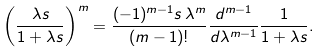Convert formula to latex. <formula><loc_0><loc_0><loc_500><loc_500>\left ( \frac { \lambda s } { 1 + \lambda s } \right ) ^ { m } = \frac { ( - 1 ) ^ { m - 1 } s \, \lambda ^ { m } } { ( m - 1 ) ! } \frac { d ^ { m - 1 } } { d \lambda ^ { m - 1 } } \frac { 1 } { 1 + \lambda s } .</formula> 